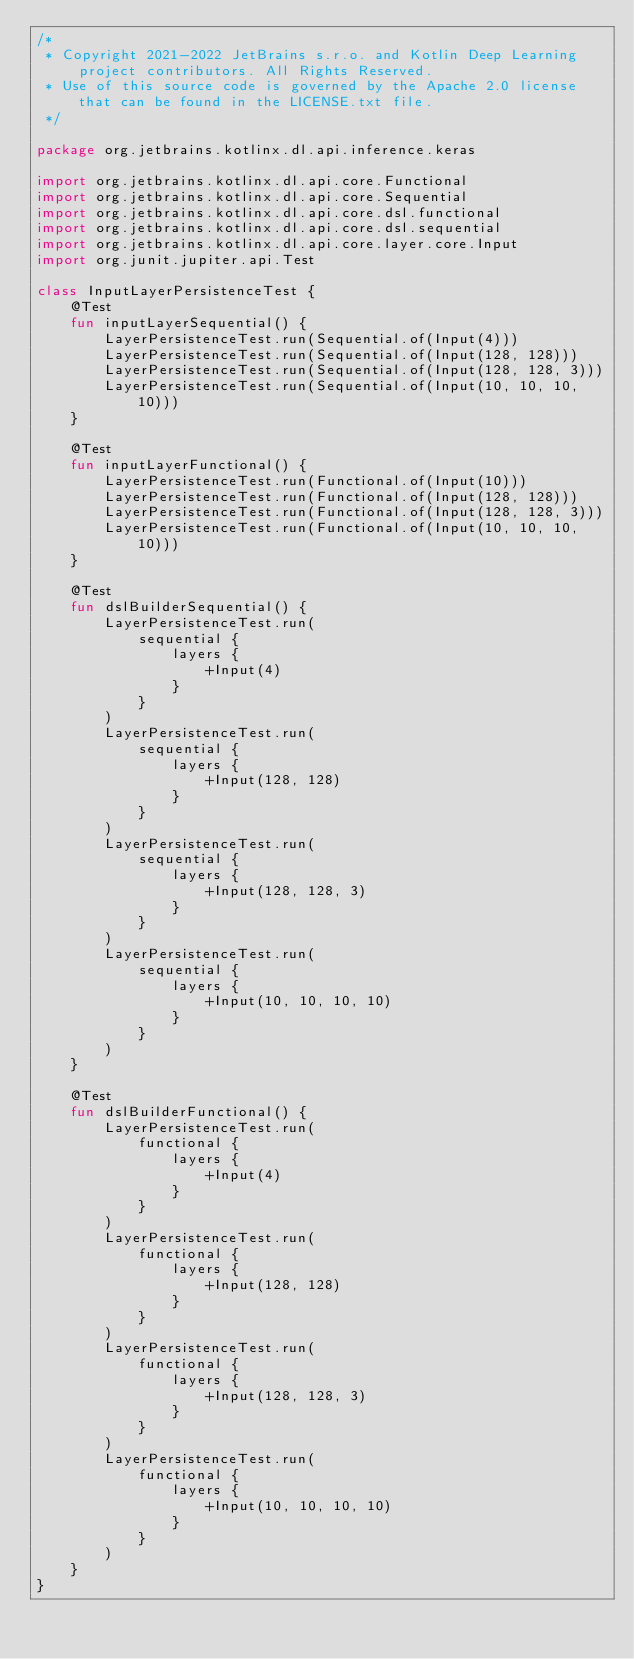<code> <loc_0><loc_0><loc_500><loc_500><_Kotlin_>/*
 * Copyright 2021-2022 JetBrains s.r.o. and Kotlin Deep Learning project contributors. All Rights Reserved.
 * Use of this source code is governed by the Apache 2.0 license that can be found in the LICENSE.txt file.
 */

package org.jetbrains.kotlinx.dl.api.inference.keras

import org.jetbrains.kotlinx.dl.api.core.Functional
import org.jetbrains.kotlinx.dl.api.core.Sequential
import org.jetbrains.kotlinx.dl.api.core.dsl.functional
import org.jetbrains.kotlinx.dl.api.core.dsl.sequential
import org.jetbrains.kotlinx.dl.api.core.layer.core.Input
import org.junit.jupiter.api.Test

class InputLayerPersistenceTest {
    @Test
    fun inputLayerSequential() {
        LayerPersistenceTest.run(Sequential.of(Input(4)))
        LayerPersistenceTest.run(Sequential.of(Input(128, 128)))
        LayerPersistenceTest.run(Sequential.of(Input(128, 128, 3)))
        LayerPersistenceTest.run(Sequential.of(Input(10, 10, 10, 10)))
    }

    @Test
    fun inputLayerFunctional() {
        LayerPersistenceTest.run(Functional.of(Input(10)))
        LayerPersistenceTest.run(Functional.of(Input(128, 128)))
        LayerPersistenceTest.run(Functional.of(Input(128, 128, 3)))
        LayerPersistenceTest.run(Functional.of(Input(10, 10, 10, 10)))
    }

    @Test
    fun dslBuilderSequential() {
        LayerPersistenceTest.run(
            sequential {
                layers {
                    +Input(4)
                }
            }
        )
        LayerPersistenceTest.run(
            sequential {
                layers {
                    +Input(128, 128)
                }
            }
        )
        LayerPersistenceTest.run(
            sequential {
                layers {
                    +Input(128, 128, 3)
                }
            }
        )
        LayerPersistenceTest.run(
            sequential {
                layers {
                    +Input(10, 10, 10, 10)
                }
            }
        )
    }

    @Test
    fun dslBuilderFunctional() {
        LayerPersistenceTest.run(
            functional {
                layers {
                    +Input(4)
                }
            }
        )
        LayerPersistenceTest.run(
            functional {
                layers {
                    +Input(128, 128)
                }
            }
        )
        LayerPersistenceTest.run(
            functional {
                layers {
                    +Input(128, 128, 3)
                }
            }
        )
        LayerPersistenceTest.run(
            functional {
                layers {
                    +Input(10, 10, 10, 10)
                }
            }
        )
    }
}
</code> 